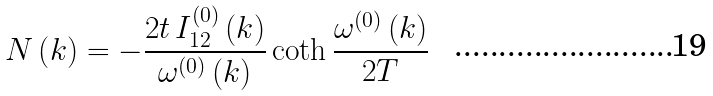Convert formula to latex. <formula><loc_0><loc_0><loc_500><loc_500>N \left ( k \right ) = - \frac { 2 t \, I ^ { ( 0 ) } _ { 1 2 } \left ( k \right ) } { \omega ^ { ( 0 ) } \left ( k \right ) } \coth \frac { \omega ^ { ( 0 ) } \left ( k \right ) } { 2 T }</formula> 